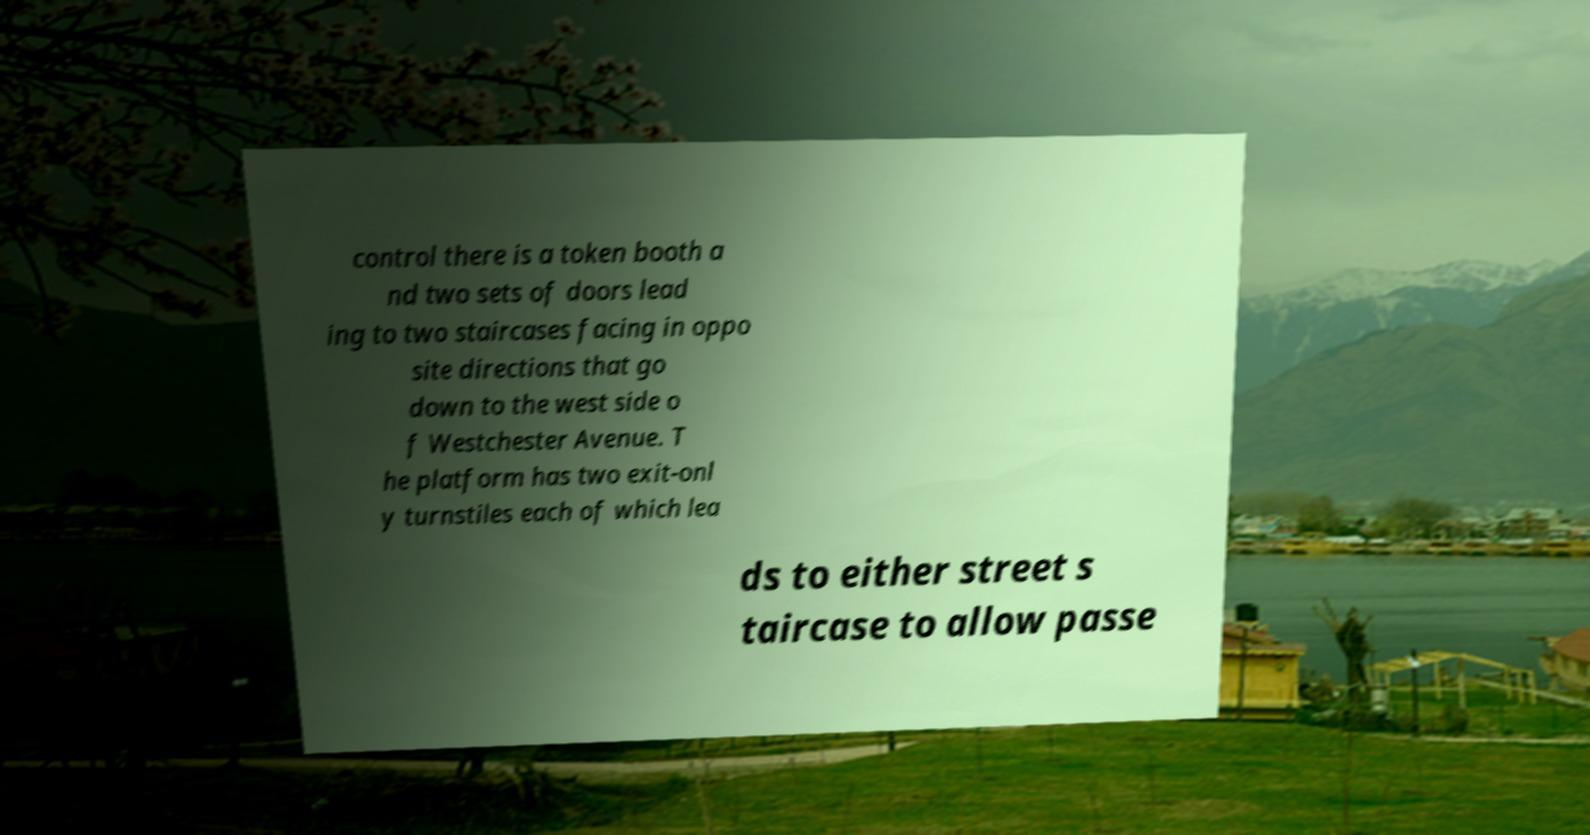Can you accurately transcribe the text from the provided image for me? control there is a token booth a nd two sets of doors lead ing to two staircases facing in oppo site directions that go down to the west side o f Westchester Avenue. T he platform has two exit-onl y turnstiles each of which lea ds to either street s taircase to allow passe 